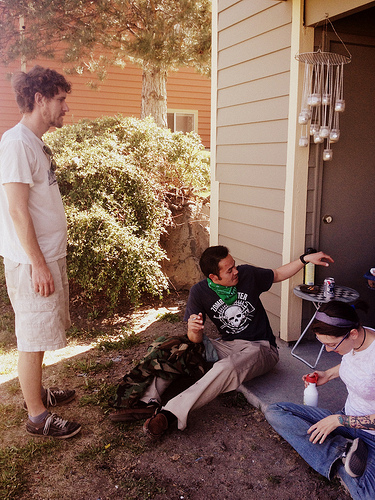<image>
Is there a bandanna on the woman? No. The bandanna is not positioned on the woman. They may be near each other, but the bandanna is not supported by or resting on top of the woman. 